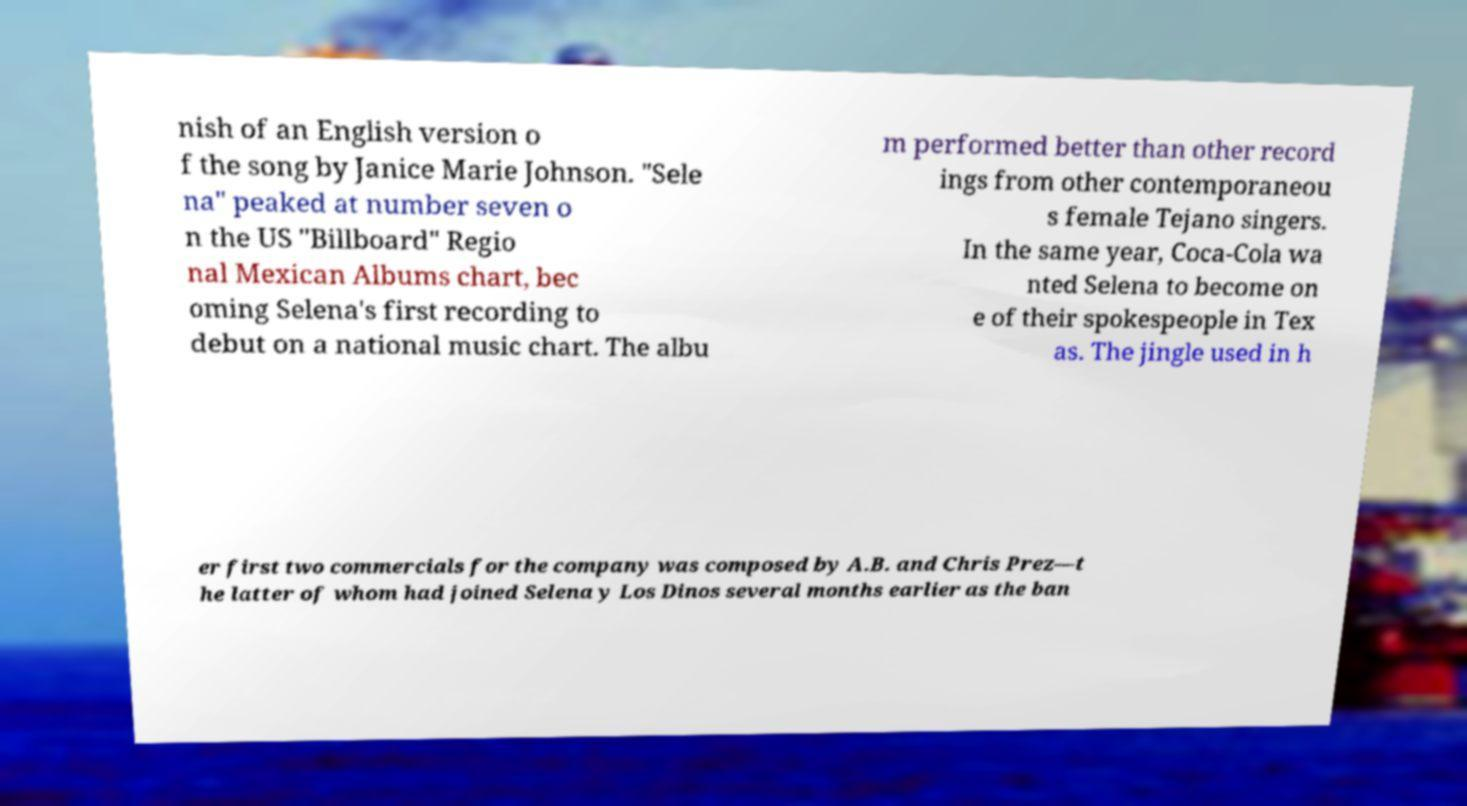Can you accurately transcribe the text from the provided image for me? nish of an English version o f the song by Janice Marie Johnson. "Sele na" peaked at number seven o n the US "Billboard" Regio nal Mexican Albums chart, bec oming Selena's first recording to debut on a national music chart. The albu m performed better than other record ings from other contemporaneou s female Tejano singers. In the same year, Coca-Cola wa nted Selena to become on e of their spokespeople in Tex as. The jingle used in h er first two commercials for the company was composed by A.B. and Chris Prez—t he latter of whom had joined Selena y Los Dinos several months earlier as the ban 